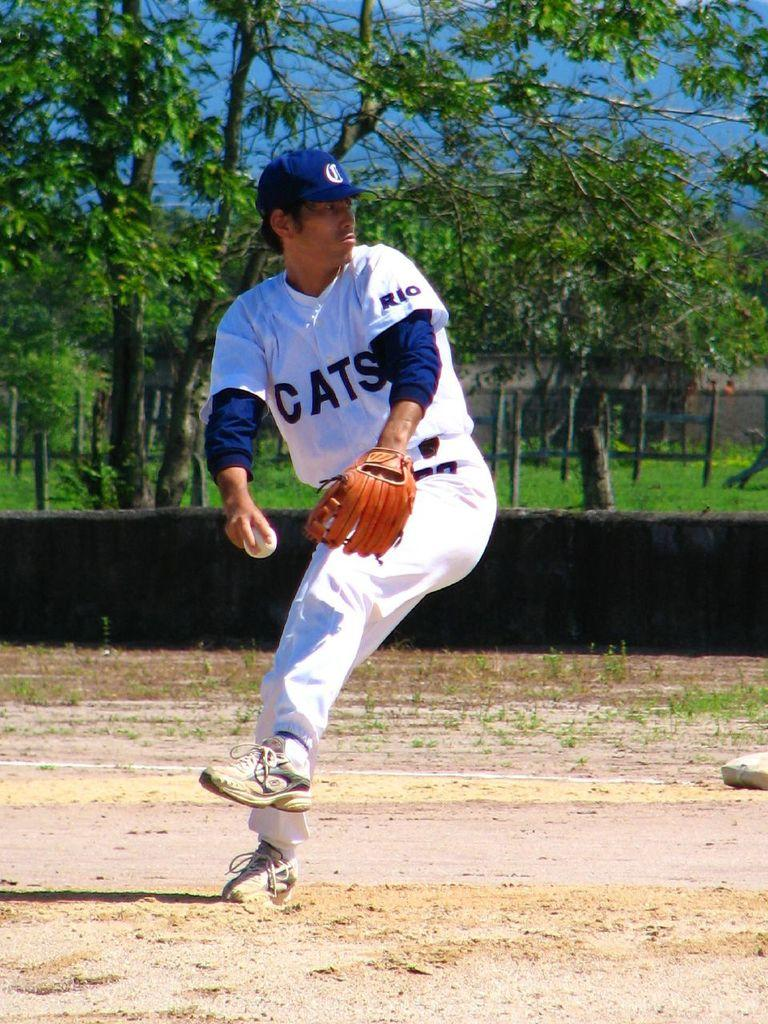<image>
Relay a brief, clear account of the picture shown. a person that is wearing a cats jersey on their back 